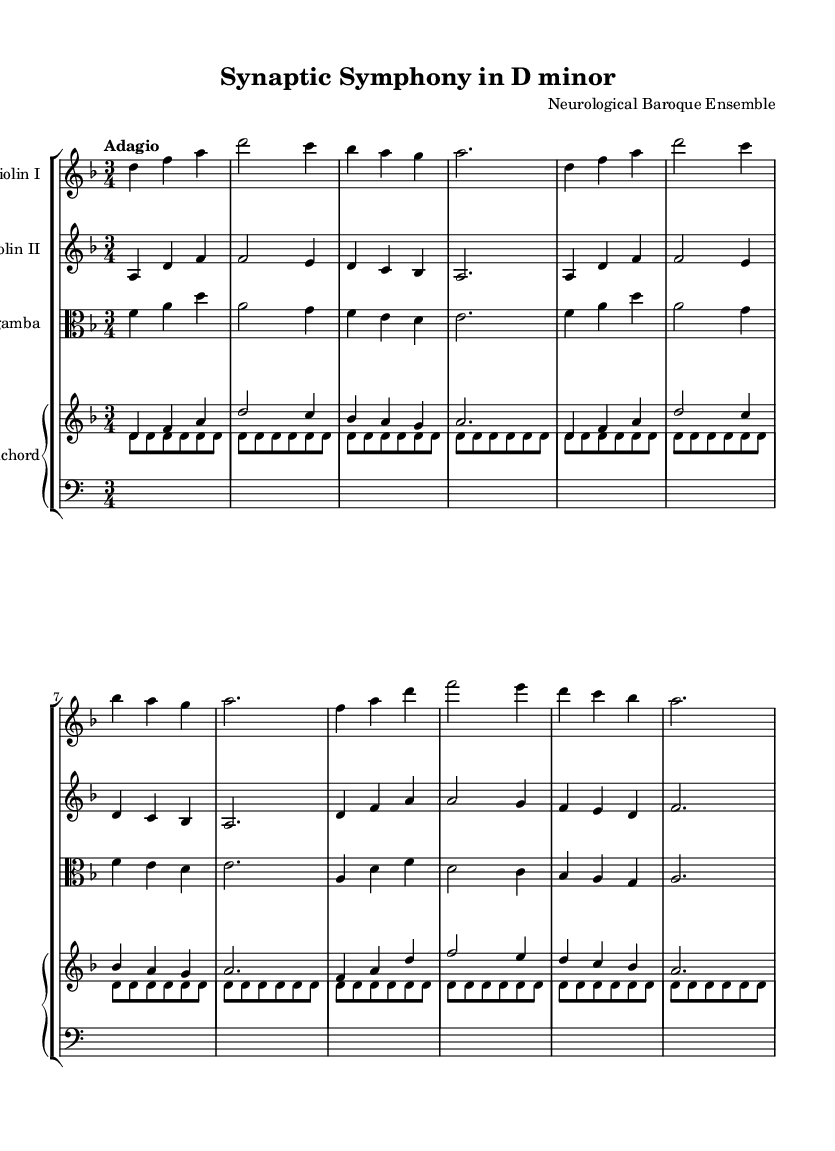What is the key signature of this music? The key signature for this piece is D minor, which has one flat (B flat). This can be identified in the global section where the key is stated explicitly.
Answer: D minor What is the time signature of this music? The time signature is 3/4, as indicated in the global section of the music. This means there are three beats in each measure, and the quarter note gets one beat.
Answer: 3/4 What is the tempo marking for this piece? The tempo marking is "Adagio," which suggests that the piece should be played slowly and gracefully. This is also found in the global section of the composition.
Answer: Adagio How many sections are present in the music? There are three main sections: Introduction, Theme A, and Theme B. Each of these sections is marked and consists of different musical material, allowing for a variation in composition.
Answer: 3 What is the instrument combination in this score? The instrument combination consists of Violin I, Violin II, Viola da gamba, and Harpsichord. Each instrument is labeled clearly at the top of its respective staff in the score.
Answer: Violin I, Violin II, Viola da gamba, Harpsichord Which theme features the note F prominently in the melody? Theme B features the note F prominently in the melody line. It can be observed as the leading note at the beginning of the section in both Violin I and Viola parts.
Answer: Theme B How is the harpsichord part structured in terms of harmony? The harpsichord part includes a blend of chords played in the upper staff and a repetitive bass line in the lower staff. The upper staff plays chords that align with the thematic material, while the lower staff provides continuous support through sustained notes.
Answer: Upper and lower staff 